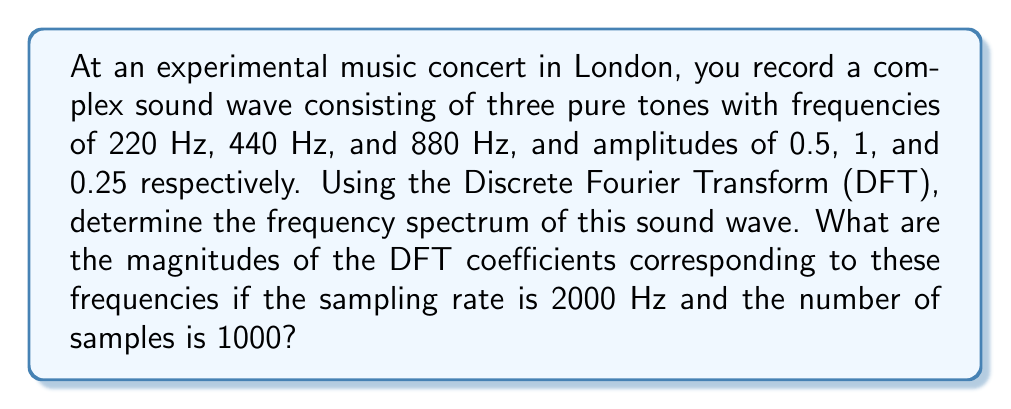What is the answer to this math problem? Let's approach this step-by-step:

1) The Discrete Fourier Transform (DFT) of a signal $x[n]$ is given by:

   $$X[k] = \sum_{n=0}^{N-1} x[n] e^{-j2\pi kn/N}$$

   where $N$ is the number of samples.

2) In this case, our signal is a sum of three sinusoids:

   $$x[n] = 0.5\sin(2\pi\cdot220n/f_s) + \sin(2\pi\cdot440n/f_s) + 0.25\sin(2\pi\cdot880n/f_s)$$

   where $f_s = 2000$ Hz is the sampling rate.

3) The frequency resolution of the DFT is given by $f_s/N = 2000/1000 = 2$ Hz.

4) The bin numbers corresponding to our frequencies are:
   - For 220 Hz: $k_1 = 220/(f_s/N) = 220/2 = 110$
   - For 440 Hz: $k_2 = 440/(f_s/N) = 440/2 = 220$
   - For 880 Hz: $k_3 = 880/(f_s/N) = 880/2 = 440$

5) For a pure sinusoid $A\sin(2\pi fn/f_s)$, the magnitude of its DFT coefficient is $N|A|/2$.

6) Therefore, the magnitudes of the DFT coefficients are:
   - For 220 Hz: $|X[110]| = 1000 \cdot 0.5/2 = 250$
   - For 440 Hz: $|X[220]| = 1000 \cdot 1/2 = 500$
   - For 880 Hz: $|X[440]| = 1000 \cdot 0.25/2 = 125$
Answer: 250, 500, 125 